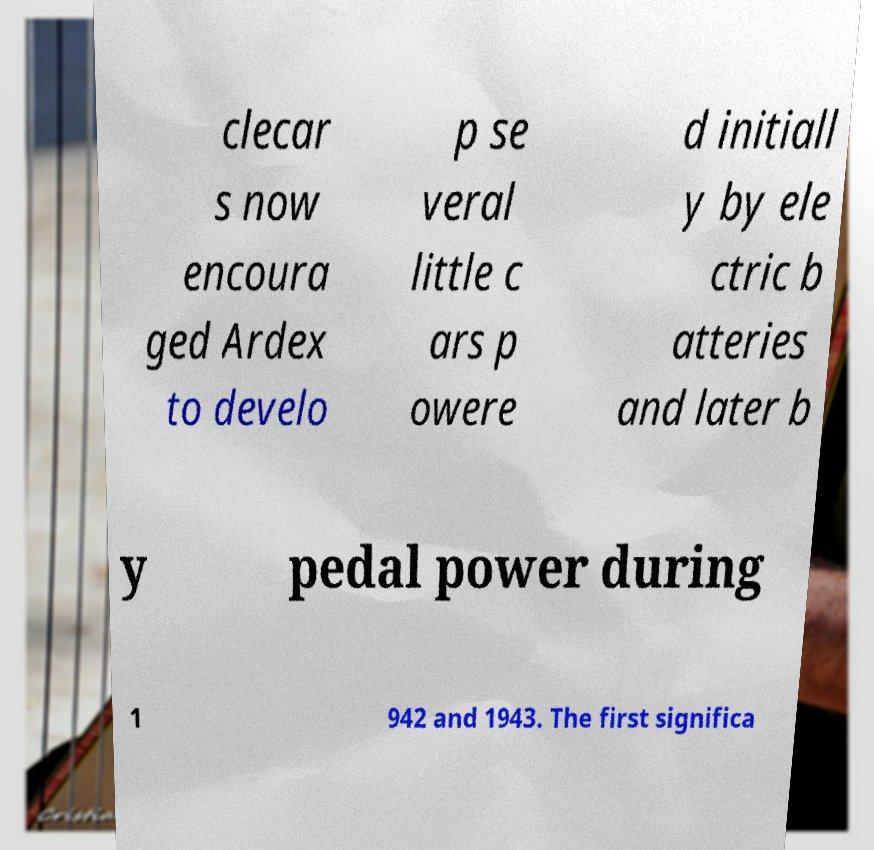Please identify and transcribe the text found in this image. clecar s now encoura ged Ardex to develo p se veral little c ars p owere d initiall y by ele ctric b atteries and later b y pedal power during 1 942 and 1943. The first significa 